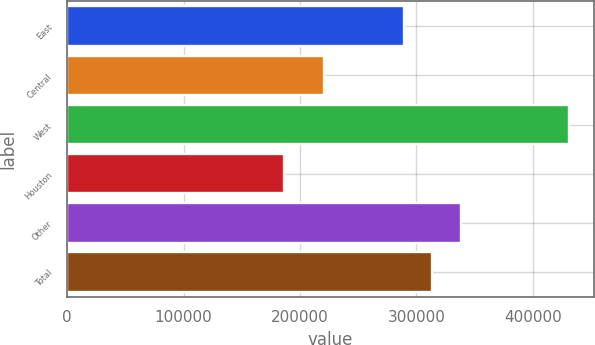Convert chart to OTSL. <chart><loc_0><loc_0><loc_500><loc_500><bar_chart><fcel>East<fcel>Central<fcel>West<fcel>Houston<fcel>Other<fcel>Total<nl><fcel>289000<fcel>221000<fcel>431000<fcel>186000<fcel>338000<fcel>313500<nl></chart> 